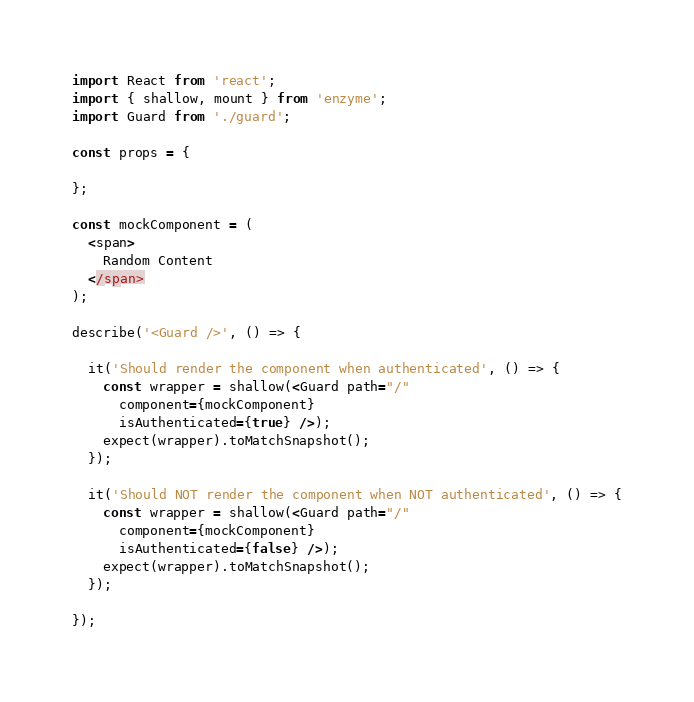<code> <loc_0><loc_0><loc_500><loc_500><_JavaScript_>import React from 'react';
import { shallow, mount } from 'enzyme';
import Guard from './guard';

const props = {

};

const mockComponent = (
  <span>
    Random Content
  </span>
);

describe('<Guard />', () => {

  it('Should render the component when authenticated', () => {
    const wrapper = shallow(<Guard path="/"
      component={mockComponent}
      isAuthenticated={true} />);
    expect(wrapper).toMatchSnapshot();
  });

  it('Should NOT render the component when NOT authenticated', () => {
    const wrapper = shallow(<Guard path="/"
      component={mockComponent}
      isAuthenticated={false} />);
    expect(wrapper).toMatchSnapshot();
  });

});</code> 